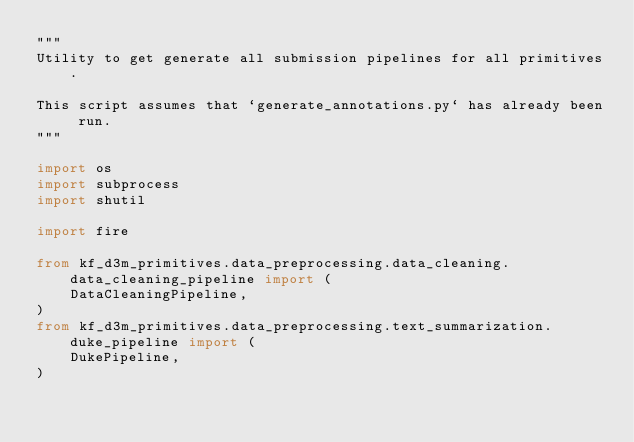<code> <loc_0><loc_0><loc_500><loc_500><_Python_>"""
Utility to get generate all submission pipelines for all primitives. 

This script assumes that `generate_annotations.py` has already been run.
"""

import os
import subprocess
import shutil

import fire

from kf_d3m_primitives.data_preprocessing.data_cleaning.data_cleaning_pipeline import (
    DataCleaningPipeline,
)
from kf_d3m_primitives.data_preprocessing.text_summarization.duke_pipeline import (
    DukePipeline,
)</code> 